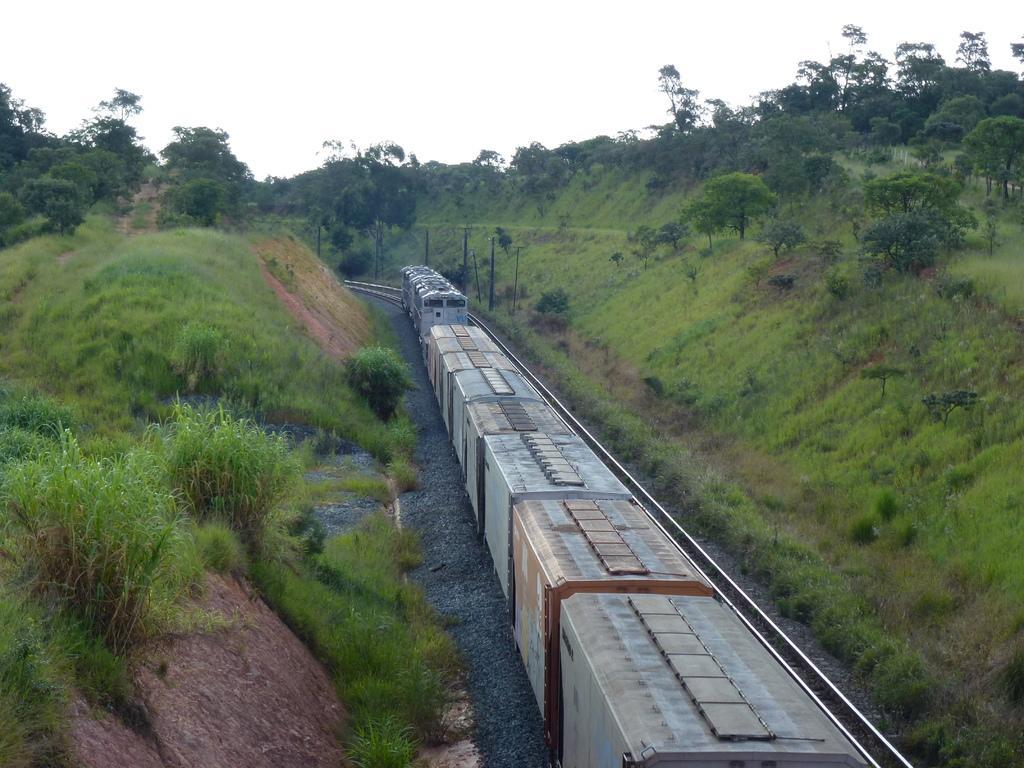Describe this image in one or two sentences. In this image in the center there is a train running on the railway track and on the left side there are plants, there's grass on the ground and there are trees. On the right side there are trees, there's grass on the ground and in the background there are trees. 